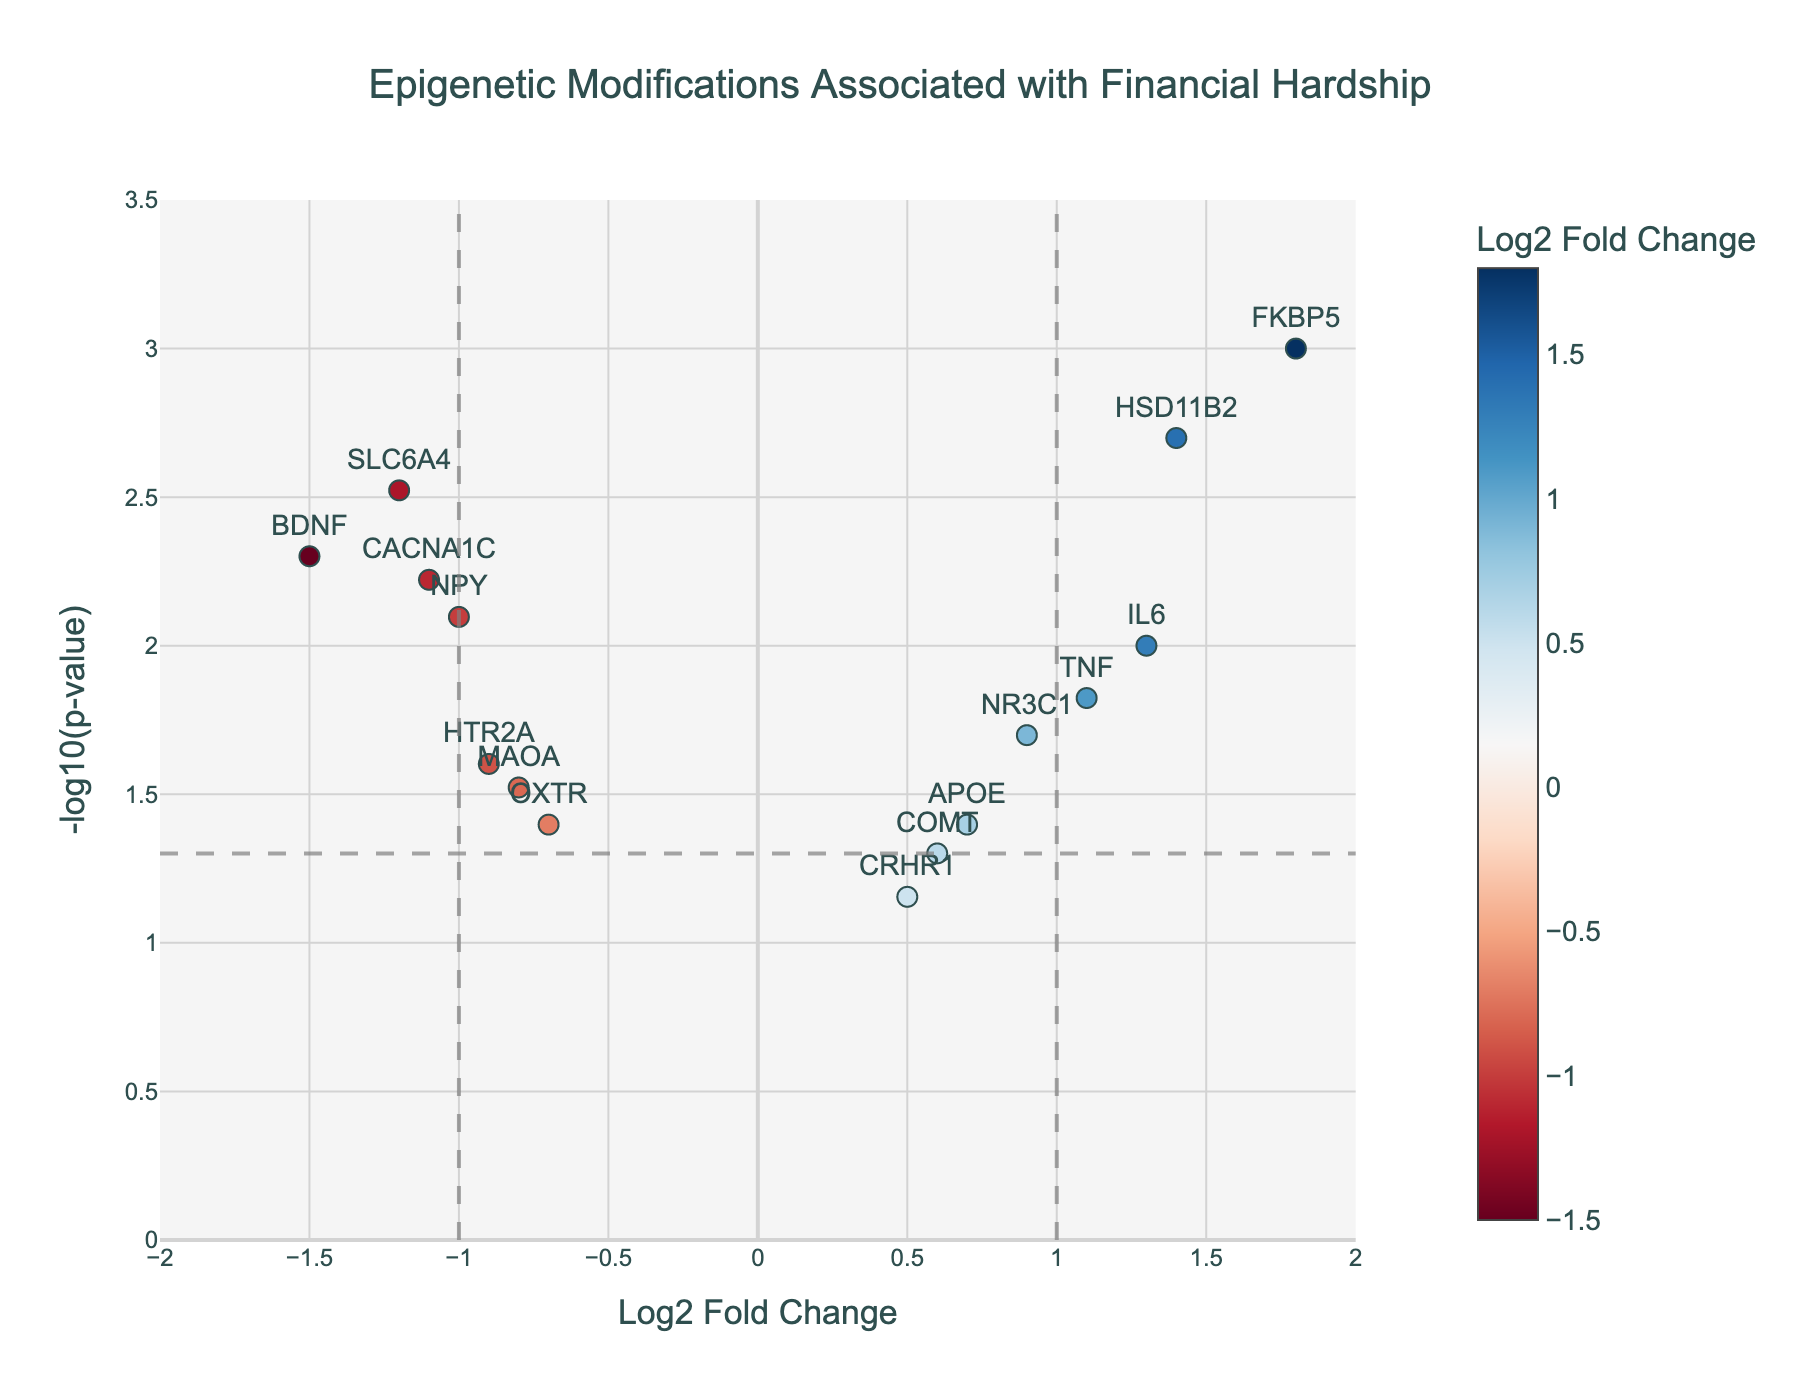What is the title of the figure? The title is prominently displayed at the top center of the figure in a larger font.
Answer: Epigenetic Modifications Associated with Financial Hardship How many genes are plotted in the figure? You can count the number of points (genes) displayed in the scatter plot.
Answer: 15 What does the color of the data points represent? The color scale to the right of the plot indicates that it represents the Log2 Fold Change values.
Answer: Log2 Fold Change Which gene has the highest Log2 Fold Change? By looking at the x-axis values, the gene on the far right indicates the highest Log2 Fold Change.
Answer: FKBP5 How many genes have a p-value less than 0.05? To find this, count the points above the horizontal dashed line representing the p-value threshold of 0.05.
Answer: 12 Which gene is closest to the origin (0,0)? Find the point nearest to where the Log2 Fold Change and -log10(p-value) axes intersect.
Answer: CRHR1 Which gene has the lowest p-value? The higher the -log10(p-value), the lower the p-value. Identify the point highest on the y-axis.
Answer: FKBP5 Which gene exhibits the highest absolute value of Log2 Fold Change? To determine this, compare the genes with the largest positive and negative Log2 Fold Changes.
Answer: FKBP5 How many genes have a Log2 Fold Change between -1 and 1 and a p-value less than 0.05? Count the points within the vertical dashed lines at x=-1 and x=1 and above the horizontal dashed line at y=-log10(0.05).
Answer: 4 Which gene has a Log2 Fold Change closest to 0 but a significant p-value? Look for the point closest to the y-axis (Log2 Fold Change of 0) and above the p-value threshold line.
Answer: CRHR1 